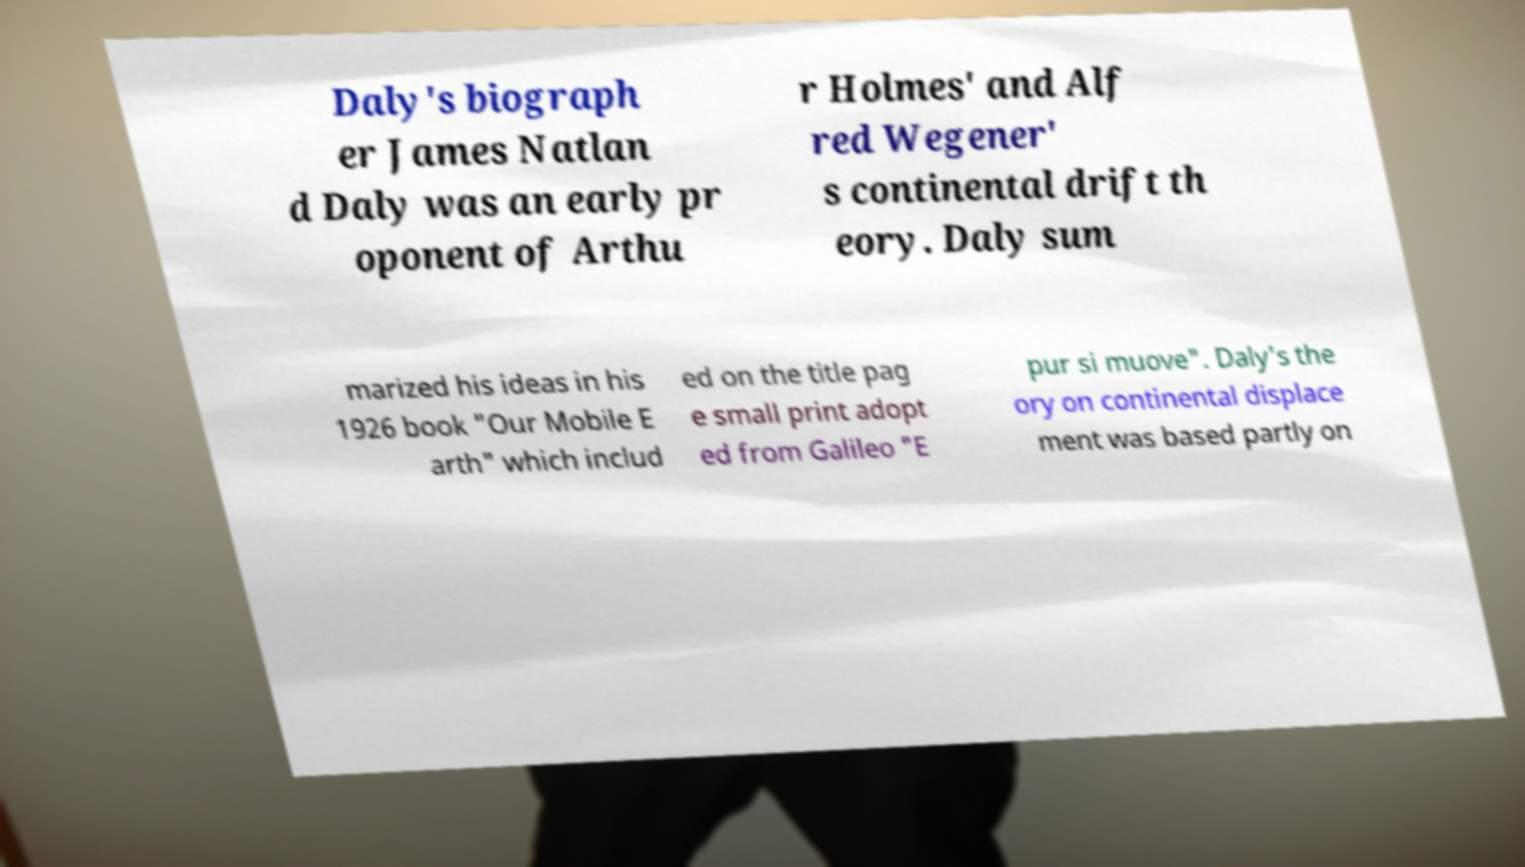I need the written content from this picture converted into text. Can you do that? Daly's biograph er James Natlan d Daly was an early pr oponent of Arthu r Holmes' and Alf red Wegener' s continental drift th eory. Daly sum marized his ideas in his 1926 book "Our Mobile E arth" which includ ed on the title pag e small print adopt ed from Galileo "E pur si muove". Daly's the ory on continental displace ment was based partly on 